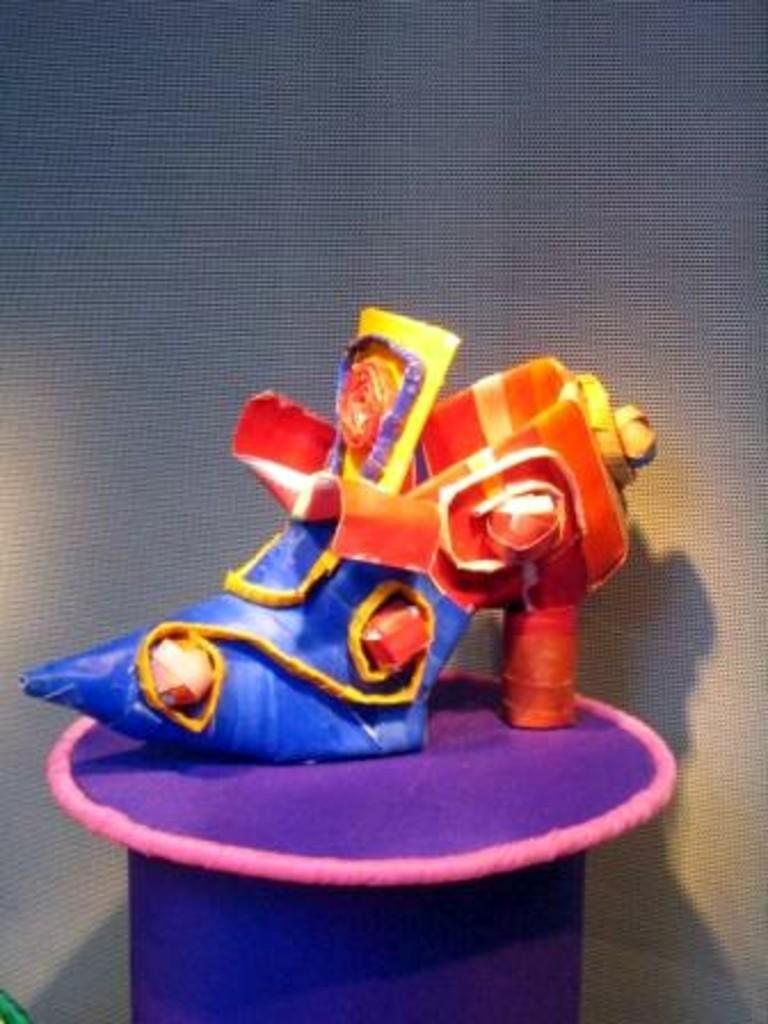What object is the main subject of the image? There is a shoe in the image. What colors are present on the shoe? The shoe has purple, red, yellow, and blue colors. What is the surface beneath the shoe like? The shoe is on a purple and pink color surface. How would you describe the background of the image? The background of the image is ash colored. Can you see a sheet being exchanged between two people in the image? There is no sheet or people present in the image; it only features a shoe on a surface with an ash-colored background. 